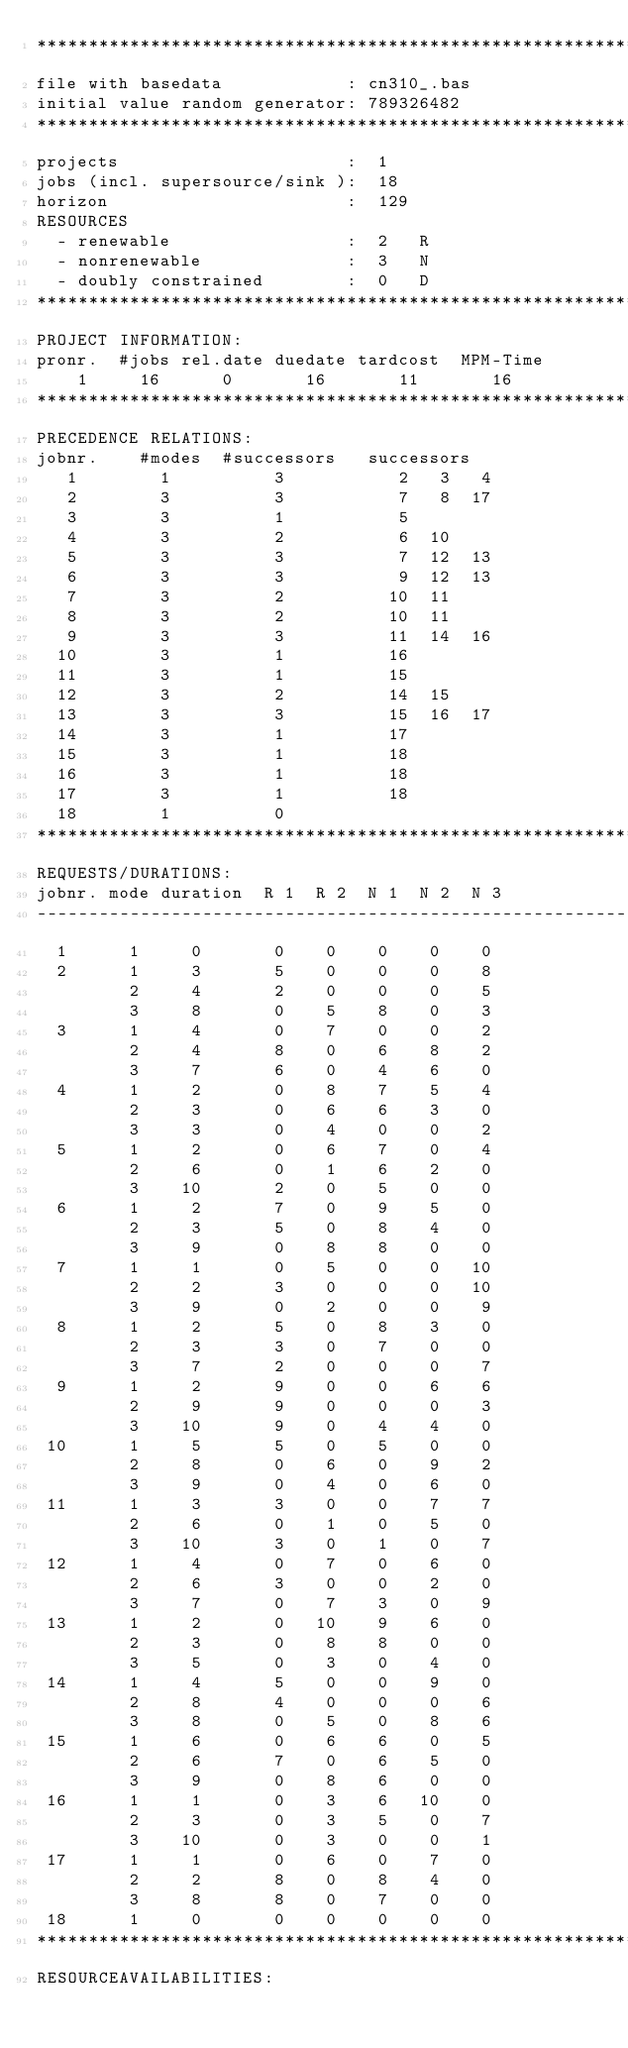Convert code to text. <code><loc_0><loc_0><loc_500><loc_500><_ObjectiveC_>************************************************************************
file with basedata            : cn310_.bas
initial value random generator: 789326482
************************************************************************
projects                      :  1
jobs (incl. supersource/sink ):  18
horizon                       :  129
RESOURCES
  - renewable                 :  2   R
  - nonrenewable              :  3   N
  - doubly constrained        :  0   D
************************************************************************
PROJECT INFORMATION:
pronr.  #jobs rel.date duedate tardcost  MPM-Time
    1     16      0       16       11       16
************************************************************************
PRECEDENCE RELATIONS:
jobnr.    #modes  #successors   successors
   1        1          3           2   3   4
   2        3          3           7   8  17
   3        3          1           5
   4        3          2           6  10
   5        3          3           7  12  13
   6        3          3           9  12  13
   7        3          2          10  11
   8        3          2          10  11
   9        3          3          11  14  16
  10        3          1          16
  11        3          1          15
  12        3          2          14  15
  13        3          3          15  16  17
  14        3          1          17
  15        3          1          18
  16        3          1          18
  17        3          1          18
  18        1          0        
************************************************************************
REQUESTS/DURATIONS:
jobnr. mode duration  R 1  R 2  N 1  N 2  N 3
------------------------------------------------------------------------
  1      1     0       0    0    0    0    0
  2      1     3       5    0    0    0    8
         2     4       2    0    0    0    5
         3     8       0    5    8    0    3
  3      1     4       0    7    0    0    2
         2     4       8    0    6    8    2
         3     7       6    0    4    6    0
  4      1     2       0    8    7    5    4
         2     3       0    6    6    3    0
         3     3       0    4    0    0    2
  5      1     2       0    6    7    0    4
         2     6       0    1    6    2    0
         3    10       2    0    5    0    0
  6      1     2       7    0    9    5    0
         2     3       5    0    8    4    0
         3     9       0    8    8    0    0
  7      1     1       0    5    0    0   10
         2     2       3    0    0    0   10
         3     9       0    2    0    0    9
  8      1     2       5    0    8    3    0
         2     3       3    0    7    0    0
         3     7       2    0    0    0    7
  9      1     2       9    0    0    6    6
         2     9       9    0    0    0    3
         3    10       9    0    4    4    0
 10      1     5       5    0    5    0    0
         2     8       0    6    0    9    2
         3     9       0    4    0    6    0
 11      1     3       3    0    0    7    7
         2     6       0    1    0    5    0
         3    10       3    0    1    0    7
 12      1     4       0    7    0    6    0
         2     6       3    0    0    2    0
         3     7       0    7    3    0    9
 13      1     2       0   10    9    6    0
         2     3       0    8    8    0    0
         3     5       0    3    0    4    0
 14      1     4       5    0    0    9    0
         2     8       4    0    0    0    6
         3     8       0    5    0    8    6
 15      1     6       0    6    6    0    5
         2     6       7    0    6    5    0
         3     9       0    8    6    0    0
 16      1     1       0    3    6   10    0
         2     3       0    3    5    0    7
         3    10       0    3    0    0    1
 17      1     1       0    6    0    7    0
         2     2       8    0    8    4    0
         3     8       8    0    7    0    0
 18      1     0       0    0    0    0    0
************************************************************************
RESOURCEAVAILABILITIES:</code> 